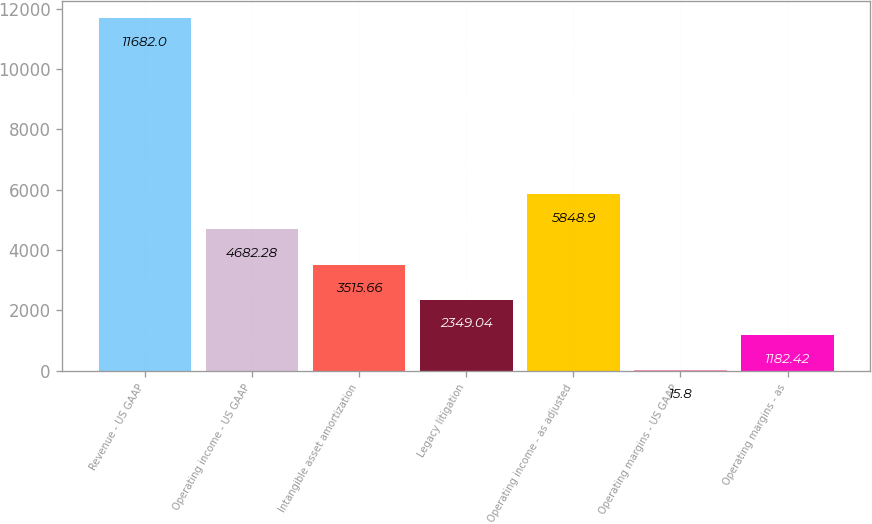<chart> <loc_0><loc_0><loc_500><loc_500><bar_chart><fcel>Revenue - US GAAP<fcel>Operating income - US GAAP<fcel>Intangible asset amortization<fcel>Legacy litigation<fcel>Operating income - as adjusted<fcel>Operating margins - US GAAP<fcel>Operating margins - as<nl><fcel>11682<fcel>4682.28<fcel>3515.66<fcel>2349.04<fcel>5848.9<fcel>15.8<fcel>1182.42<nl></chart> 